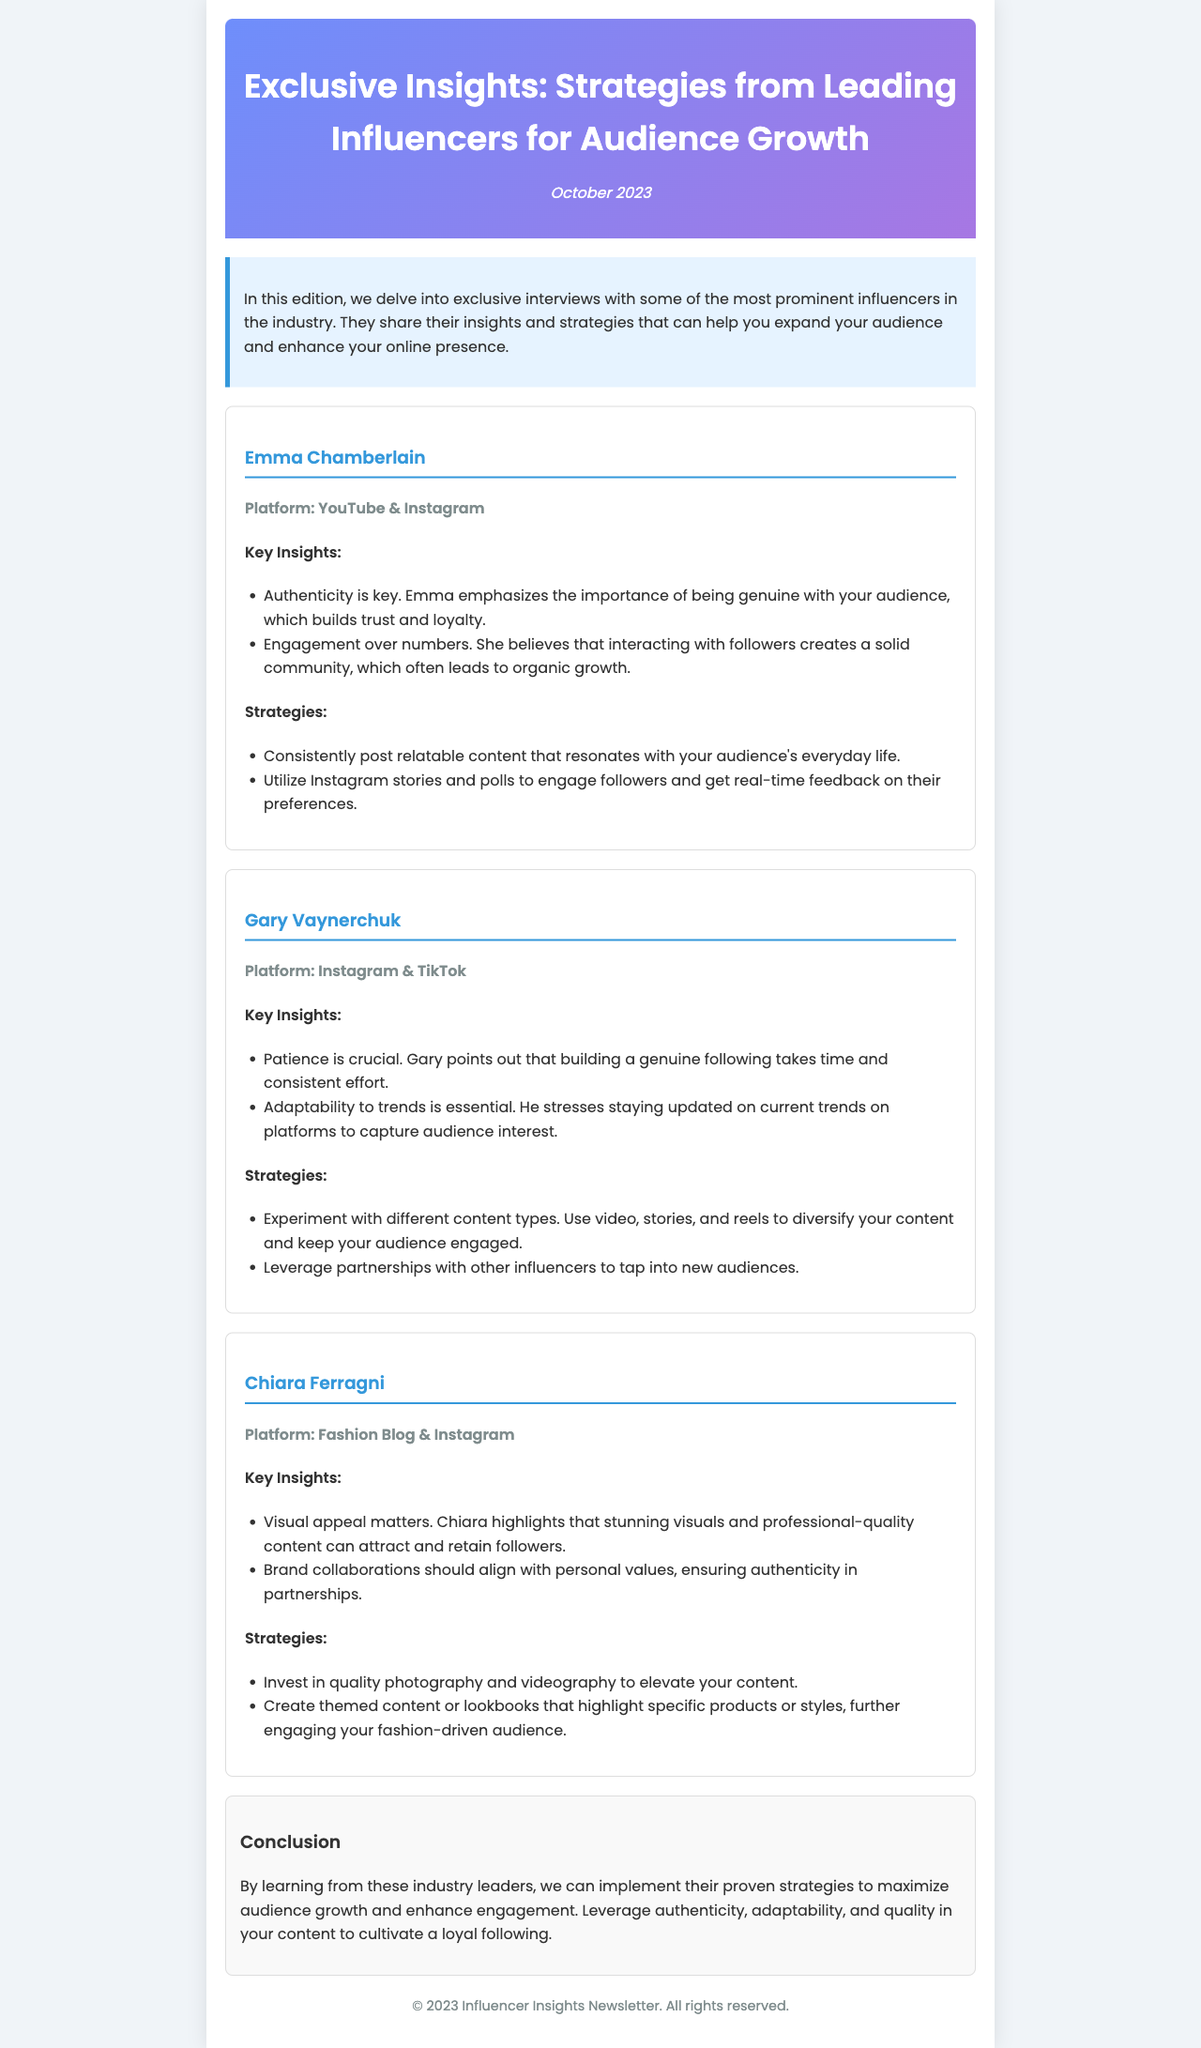What is the title of the newsletter? The title is prominently displayed in the header section of the document.
Answer: Exclusive Insights: Strategies from Leading Influencers for Audience Growth Who is featured on the platform Instagram & TikTok? The document lists influencers and their associated platforms.
Answer: Gary Vaynerchuk What is Emma Chamberlain's key insight? The insights are listed under each influencer's section, focusing on what they consider important.
Answer: Authenticity is key How many influencers are discussed in the newsletter? The document has separate sections for each influencer showcasing their insights and strategies.
Answer: Three What major strategy does Chiara Ferragni recommend? Strategies are listed under each influencer and highlight practical ways to grow an audience.
Answer: Invest in quality photography and videography What does Gary Vaynerchuk emphasize about building a following? This is a key insight he shares, reflecting on the nature of audience growth.
Answer: Patience is crucial What type of content does Emma Chamberlain suggest posting? Her strategy involves posting content that resonates with the audience, falling under relatable content.
Answer: Relatable content What color is used for the header background? The aesthetic details such as colors are part of the document's style section.
Answer: Gradient of blue and purple 